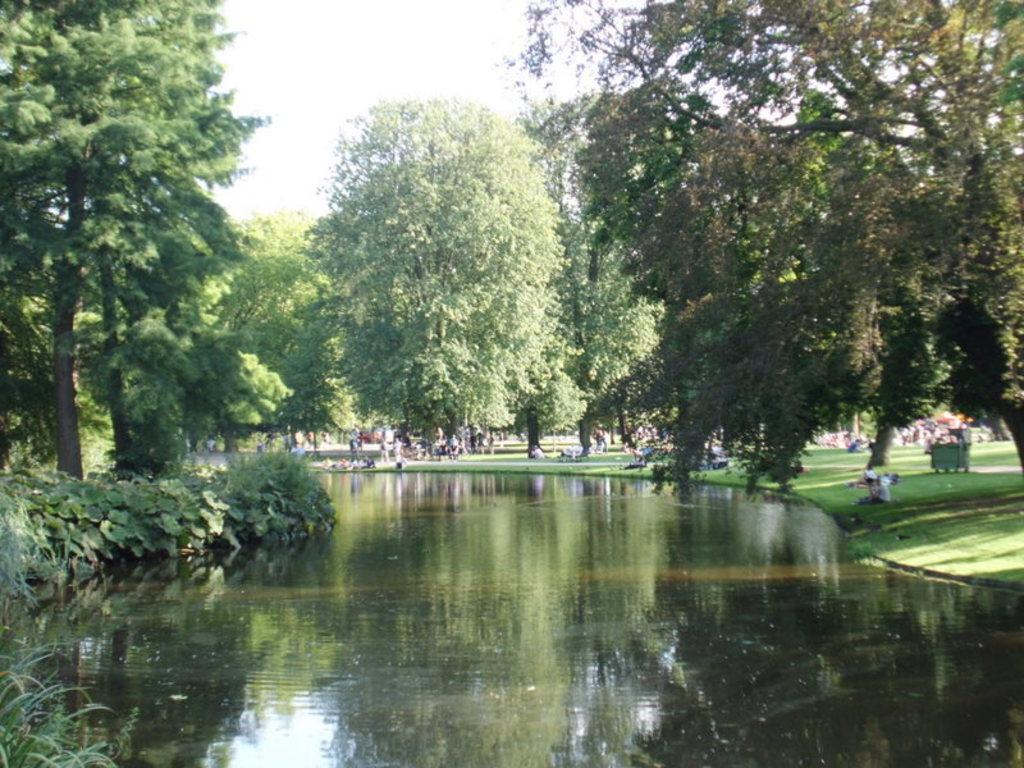What can be seen in the foreground of the image? In the foreground of the image, there is water, plants, and trees. What else is present in the foreground of the image? There are no other objects or subjects in the foreground besides the water, plants, and trees. What is visible in the background of the image? In the background of the image, there are trees and persons under the trees. What is visible at the top of the image? The sky is visible at the top of the image. Can you tell me where the note is located in the image? There is no note present in the image. What type of hospital can be seen in the background of the image? There is no hospital present in the image; it features trees and persons under the trees in the background. 